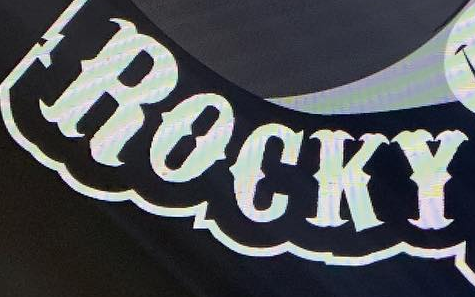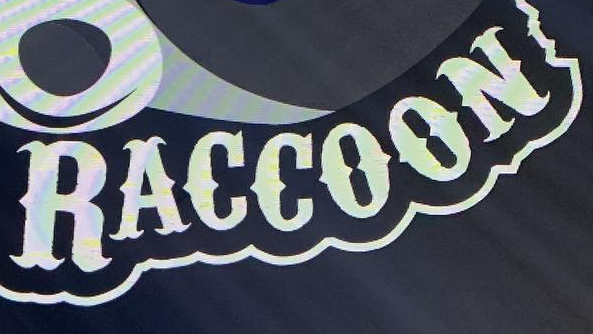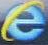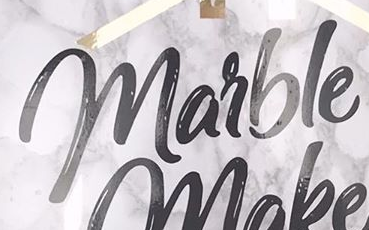Read the text from these images in sequence, separated by a semicolon. ROCKY; RACCOON; e; marble 